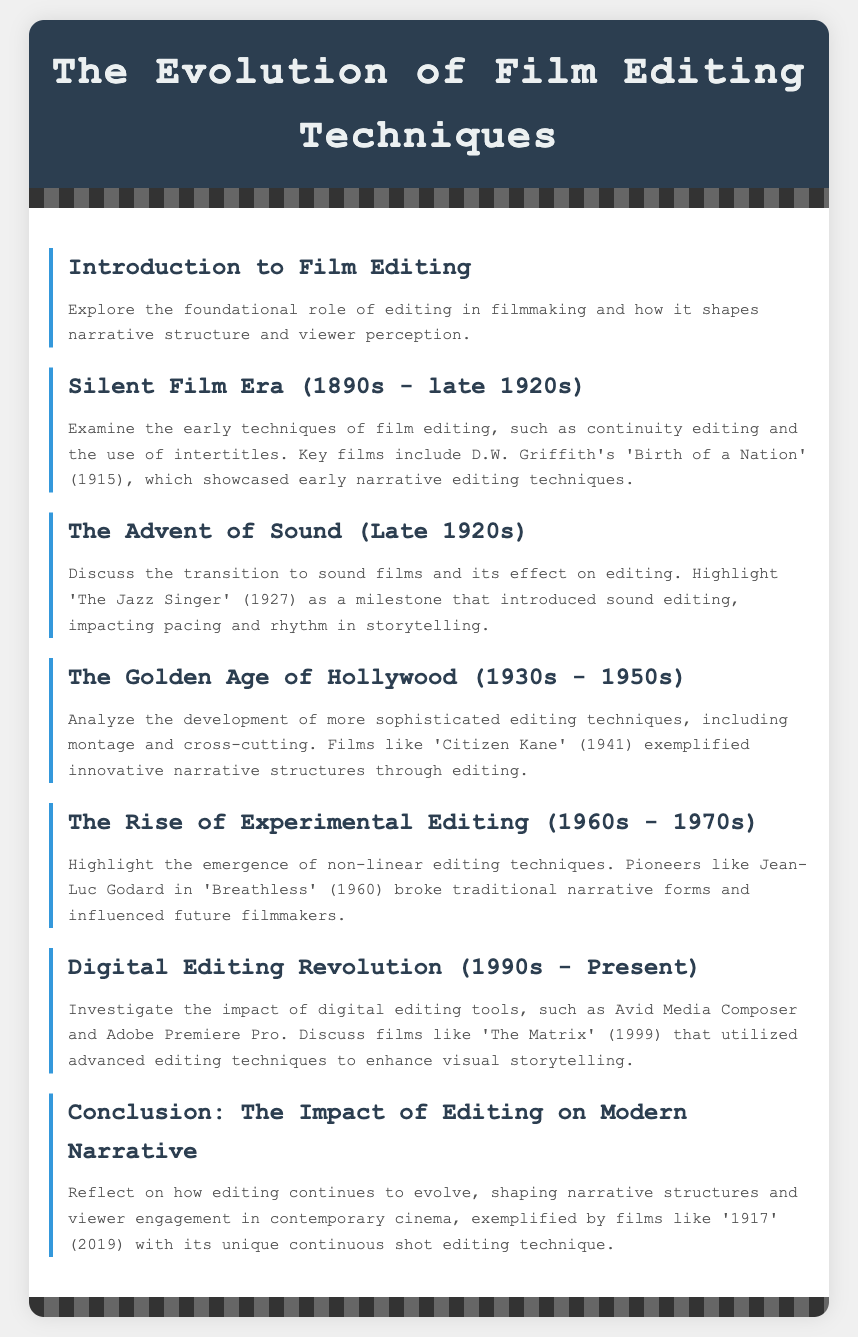What is the title of the document? The title of the document is displayed prominently at the top, stating the subject matter.
Answer: The Evolution of Film Editing Techniques What key film is associated with the silent film era? The document mentions a specific film known for its early narrative editing techniques from this era.
Answer: Birth of a Nation Which film introduced sound editing? The document identifies a pivotal film that marked the transition to sound editing and its impact on storytelling.
Answer: The Jazz Singer What decade is known as the Golden Age of Hollywood? The document specifies the time period when more sophisticated editing techniques were developed and employed.
Answer: 1930s - 1950s Who is a pioneer of experimental editing mentioned in the document? The document highlights an influential filmmaker known for breaking traditional narrative forms during this period.
Answer: Jean-Luc Godard What technology revolutionized film editing in the 1990s? The document mentions specific digital editing tools that transformed the editing processes in filmmaking.
Answer: Digital editing tools What unique editing technique is exemplified by the film '1917'? The document discusses a specific technique used in this modern film that showcases a continuous shot.
Answer: Continuous shot editing technique Which film features advanced editing techniques like those discussed in the digital revolution section? The document references a specific film that made significant use of innovative editing methods.
Answer: The Matrix What is a key aspect of editing discussed in the conclusion? The document reflects on a crucial role that editing plays in narrative structure and viewer engagement in contemporary cinema.
Answer: Evolving narrative structures 